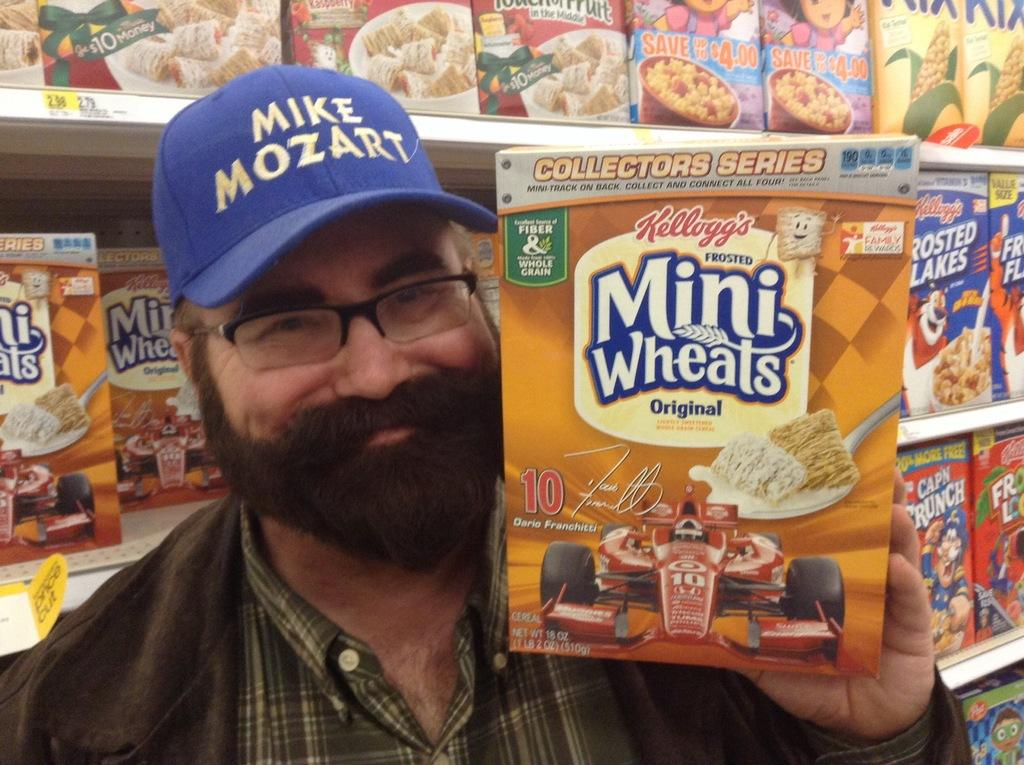What is the main subject of the image? There is a person in the image. What is the person wearing on their head? The person is wearing a cap. What is the person holding in the image? The person is holding a box. What can be seen in the background of the image? There are shelves in the background of the image. What is on the shelves? The shelves have boxes on them. What type of instrument is the scarecrow playing in the image? There is no scarecrow or instrument present in the image. How does the person hold the box with their grip? The image does not show the person's grip on the box, so it cannot be determined from the image. 